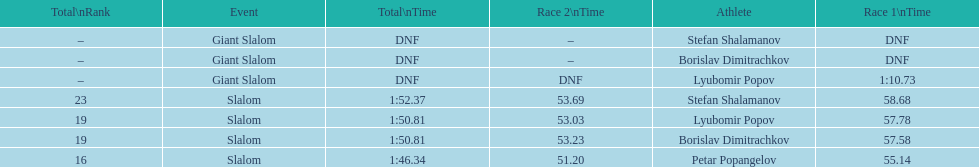Who was the other athlete who tied in rank with lyubomir popov? Borislav Dimitrachkov. 